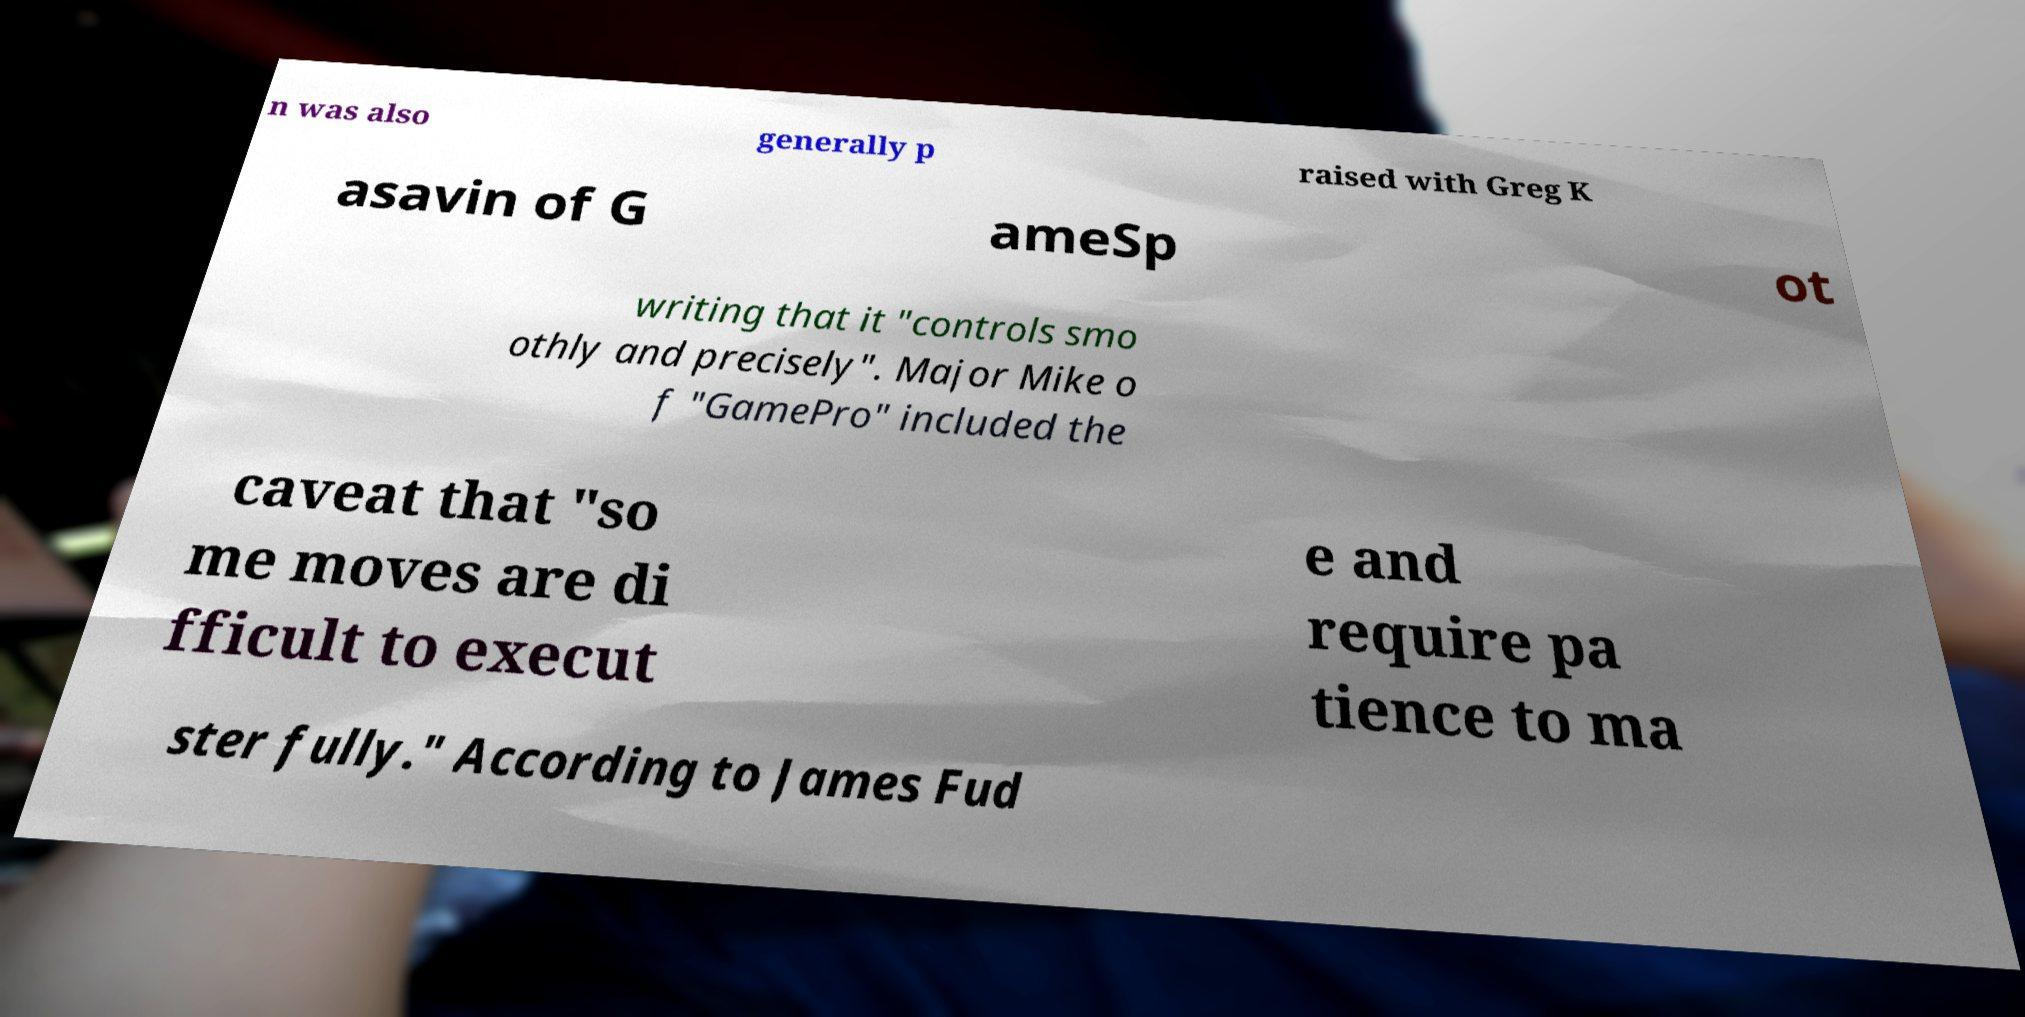Please read and relay the text visible in this image. What does it say? n was also generally p raised with Greg K asavin of G ameSp ot writing that it "controls smo othly and precisely". Major Mike o f "GamePro" included the caveat that "so me moves are di fficult to execut e and require pa tience to ma ster fully." According to James Fud 